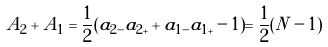<formula> <loc_0><loc_0><loc_500><loc_500>A _ { 2 } + A _ { 1 } = \frac { 1 } { 2 } ( a _ { 2 - } a _ { 2 + } + a _ { 1 - } a _ { 1 + } - 1 ) = \frac { 1 } { 2 } ( N - 1 )</formula> 